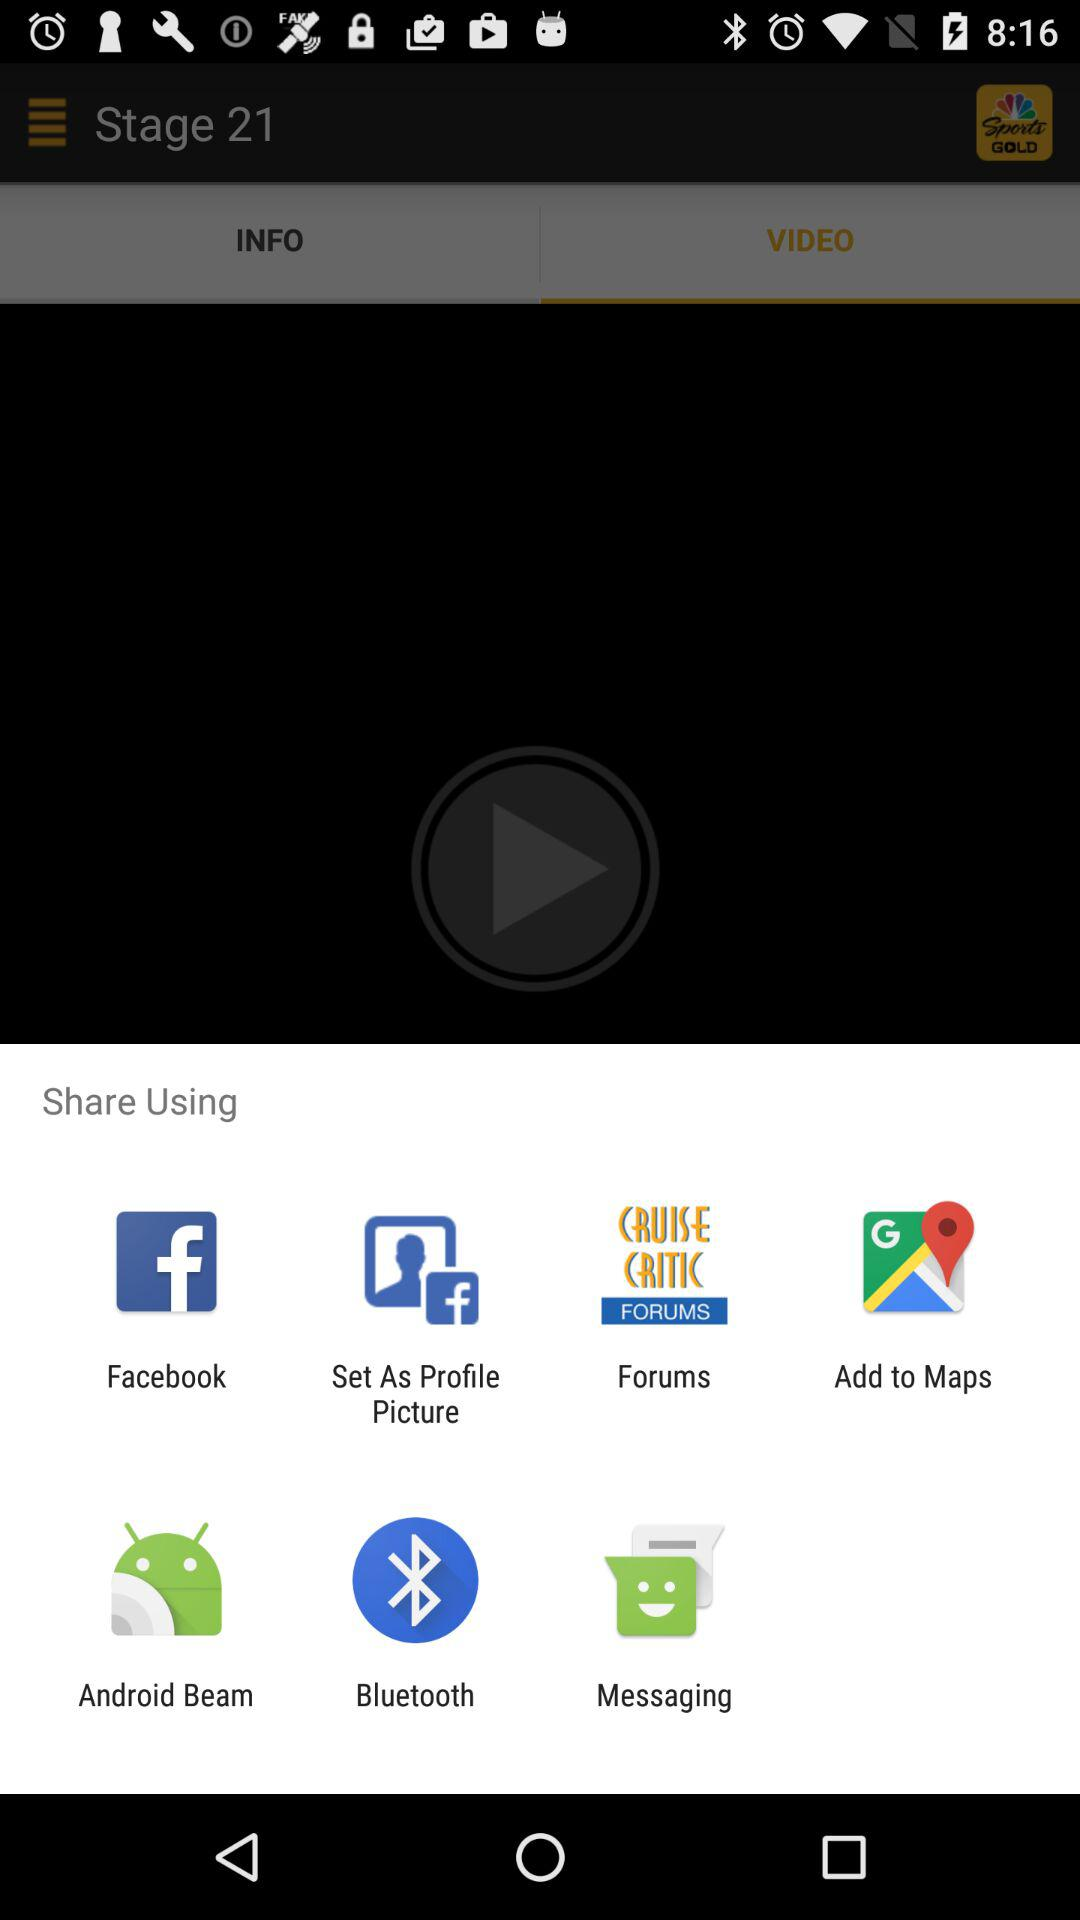What applications can I use to share the content? You can use "Facebook", "Set As Profile Picture", "Forums", "Add to Maps", "Android Beam", "Bluetooth", and "Messaging". 